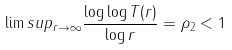<formula> <loc_0><loc_0><loc_500><loc_500>\lim s u p _ { r \to \infty } \frac { \log \log T ( r ) } { \log r } = \rho _ { 2 } < 1</formula> 